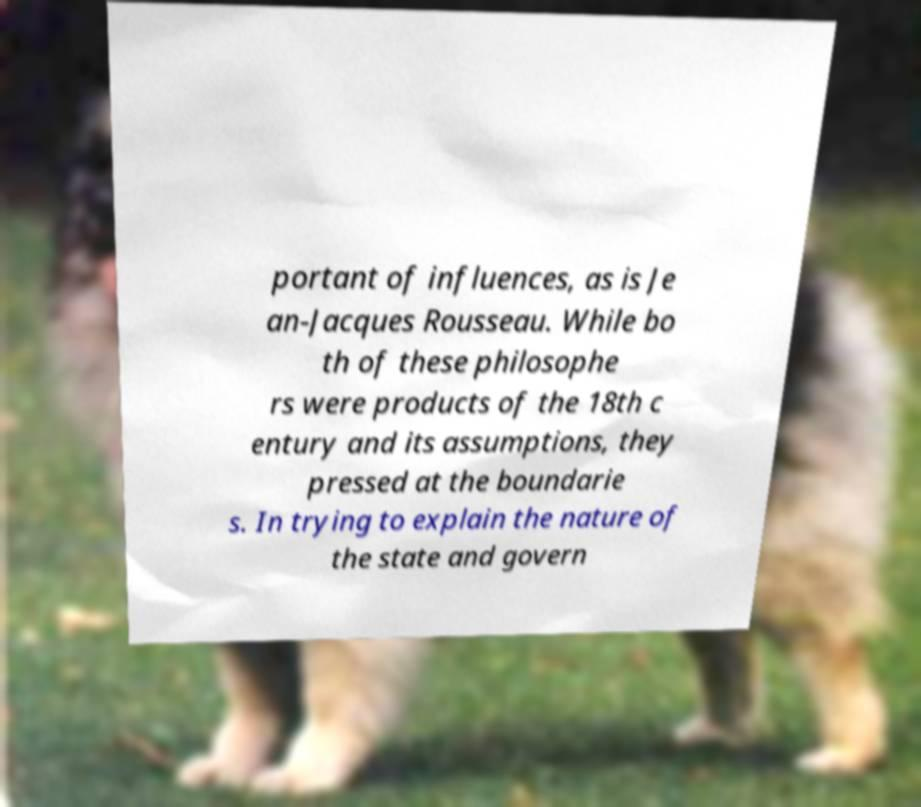Can you read and provide the text displayed in the image?This photo seems to have some interesting text. Can you extract and type it out for me? portant of influences, as is Je an-Jacques Rousseau. While bo th of these philosophe rs were products of the 18th c entury and its assumptions, they pressed at the boundarie s. In trying to explain the nature of the state and govern 